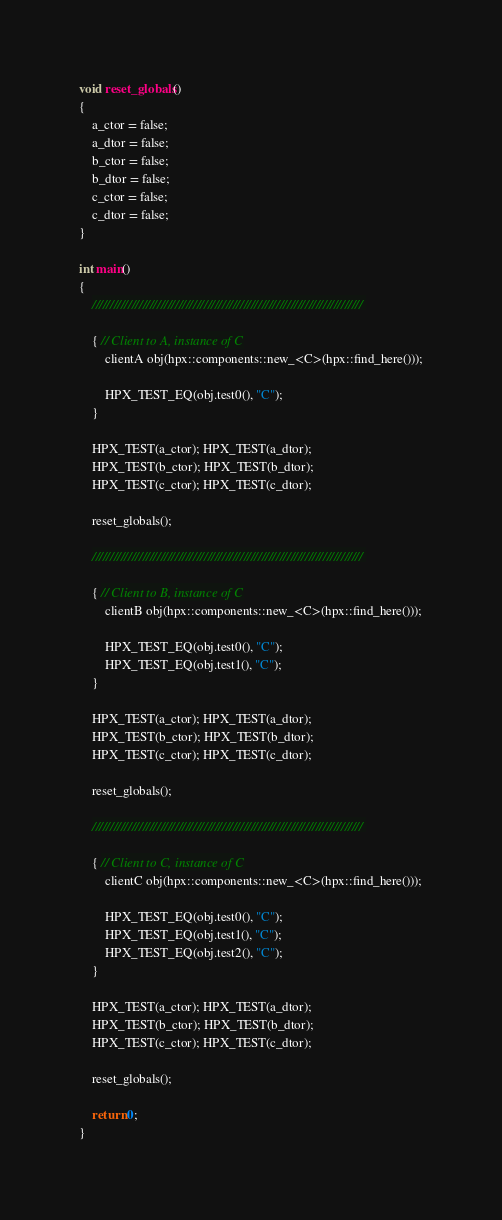<code> <loc_0><loc_0><loc_500><loc_500><_C++_>void reset_globals()
{
    a_ctor = false;
    a_dtor = false;
    b_ctor = false;
    b_dtor = false;
    c_ctor = false;
    c_dtor = false;
}

int main()
{
    ///////////////////////////////////////////////////////////////////////////

    { // Client to A, instance of C
        clientA obj(hpx::components::new_<C>(hpx::find_here()));

        HPX_TEST_EQ(obj.test0(), "C");
    }

    HPX_TEST(a_ctor); HPX_TEST(a_dtor);
    HPX_TEST(b_ctor); HPX_TEST(b_dtor);
    HPX_TEST(c_ctor); HPX_TEST(c_dtor);

    reset_globals();

    ///////////////////////////////////////////////////////////////////////////

    { // Client to B, instance of C
        clientB obj(hpx::components::new_<C>(hpx::find_here()));

        HPX_TEST_EQ(obj.test0(), "C");
        HPX_TEST_EQ(obj.test1(), "C");
    }

    HPX_TEST(a_ctor); HPX_TEST(a_dtor);
    HPX_TEST(b_ctor); HPX_TEST(b_dtor);
    HPX_TEST(c_ctor); HPX_TEST(c_dtor);

    reset_globals();

    ///////////////////////////////////////////////////////////////////////////

    { // Client to C, instance of C
        clientC obj(hpx::components::new_<C>(hpx::find_here()));

        HPX_TEST_EQ(obj.test0(), "C");
        HPX_TEST_EQ(obj.test1(), "C");
        HPX_TEST_EQ(obj.test2(), "C");
    }

    HPX_TEST(a_ctor); HPX_TEST(a_dtor);
    HPX_TEST(b_ctor); HPX_TEST(b_dtor);
    HPX_TEST(c_ctor); HPX_TEST(c_dtor);

    reset_globals();

    return 0;
}

</code> 